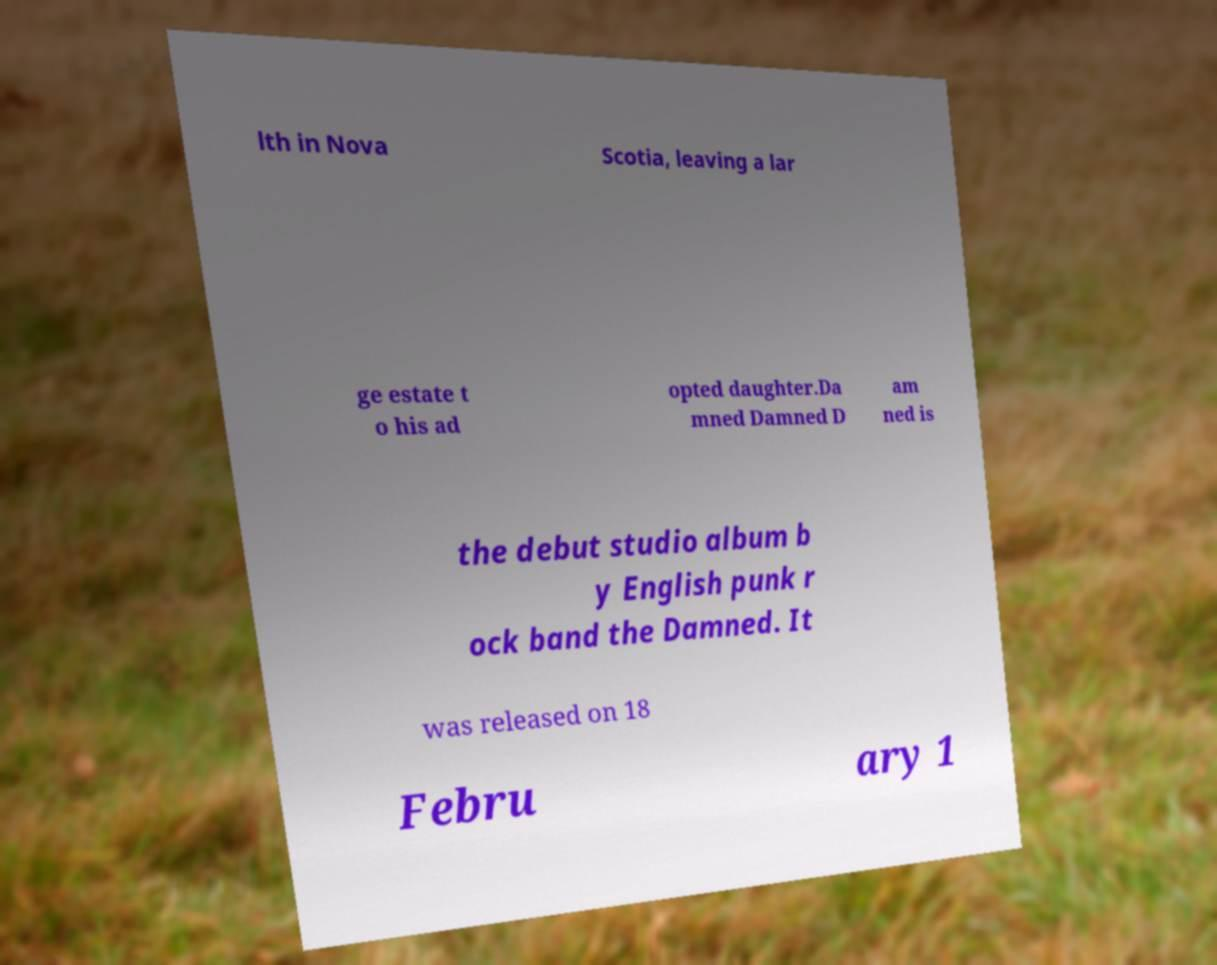What messages or text are displayed in this image? I need them in a readable, typed format. lth in Nova Scotia, leaving a lar ge estate t o his ad opted daughter.Da mned Damned D am ned is the debut studio album b y English punk r ock band the Damned. It was released on 18 Febru ary 1 